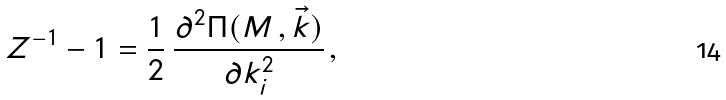<formula> <loc_0><loc_0><loc_500><loc_500>Z ^ { - 1 } - 1 = \frac { 1 } { 2 } \, \frac { \partial ^ { 2 } \Pi ( M \, , \vec { k } ) } { \partial k _ { i } ^ { 2 } } \, ,</formula> 